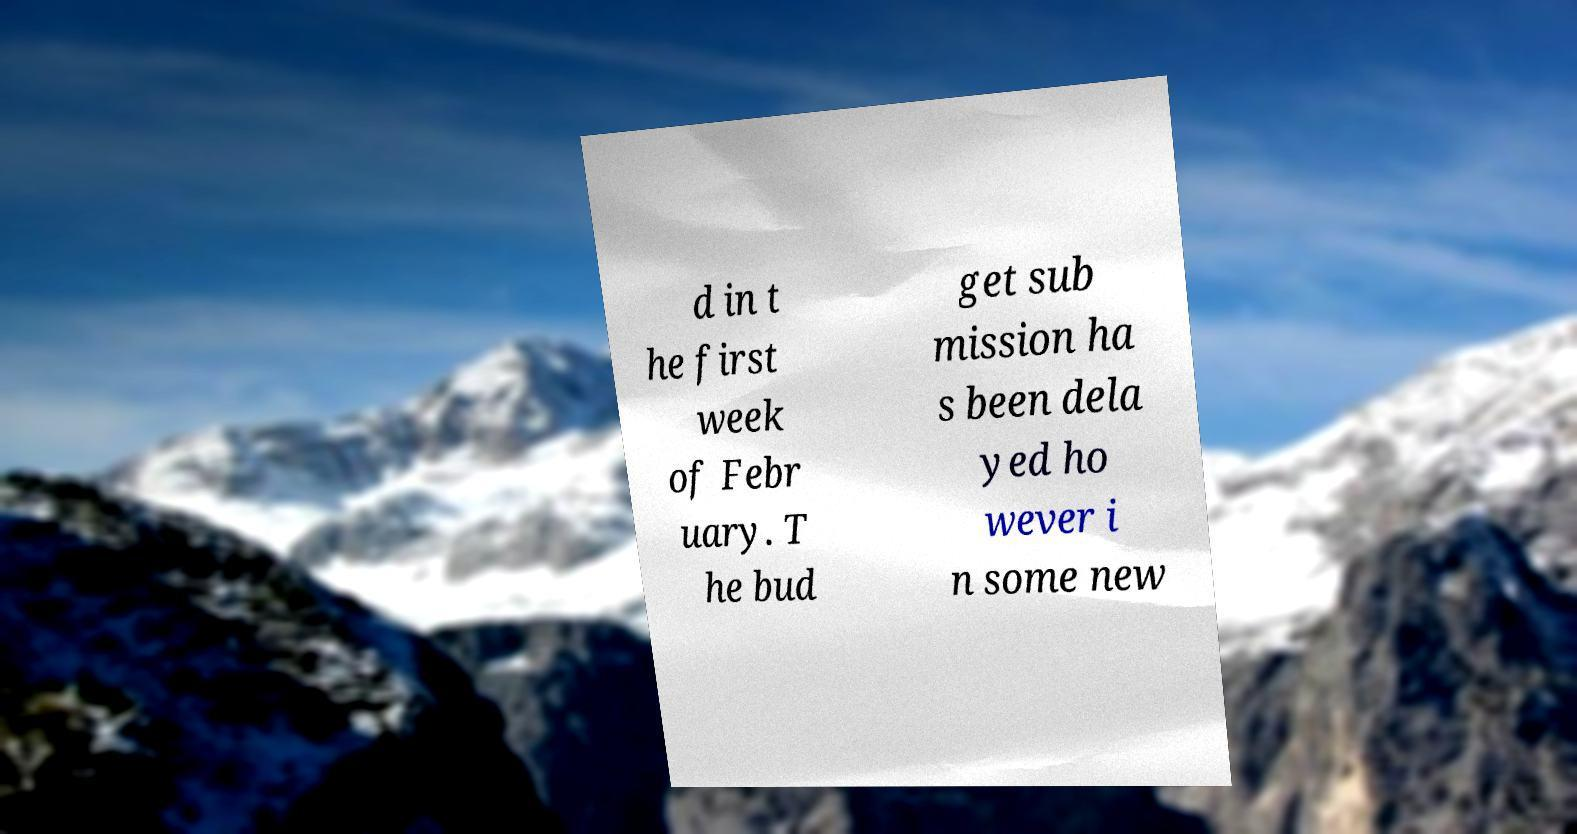Could you assist in decoding the text presented in this image and type it out clearly? d in t he first week of Febr uary. T he bud get sub mission ha s been dela yed ho wever i n some new 